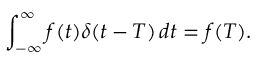Convert formula to latex. <formula><loc_0><loc_0><loc_500><loc_500>\int _ { - \infty } ^ { \infty } f ( t ) \delta ( t - T ) \, d t = f ( T ) .</formula> 